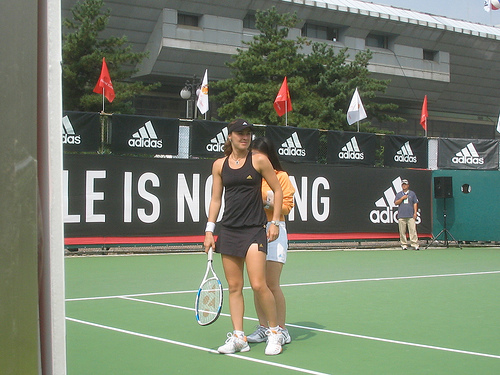<image>
Is there a woman behind the racket? Yes. From this viewpoint, the woman is positioned behind the racket, with the racket partially or fully occluding the woman. 